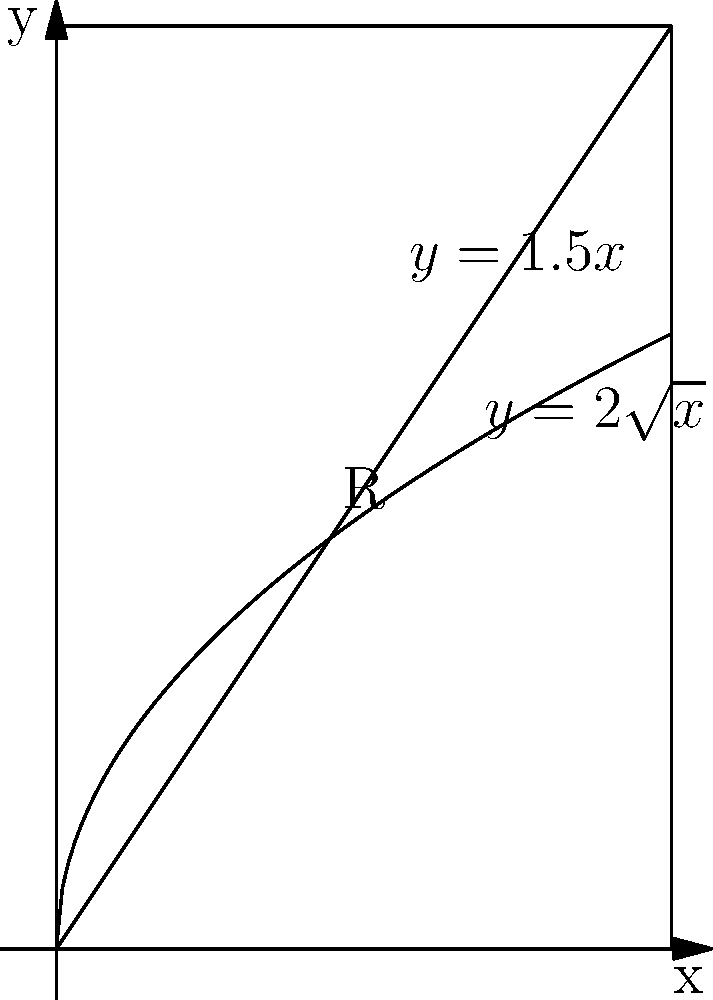As a concert promoter organizing a Queen tribute show, you're designing a cylindrical speaker stack. The cross-section of the stack is represented by the region R bounded by the curves $y=2\sqrt{x}$, $y=1.5x$, and the y-axis. If the stack is 10 feet tall, what is its volume in cubic feet? Round your answer to the nearest whole number. To find the volume of the cylindrical speaker stack, we need to follow these steps:

1) First, we need to find the area of the cross-section (region R) using the washer method.

2) The area A is given by the integral:

   $$A = \int_0^a (2\sqrt{x} - 1.5x) dx$$

   where $a$ is the x-coordinate of the intersection point of the two curves.

3) To find $a$, we solve the equation:
   
   $$2\sqrt{x} = 1.5x$$
   $$4x = 2.25x^2$$
   $$0 = 2.25x^2 - 4x = 0.25x(9x - 16)$$
   $$x = 0 \text{ or } x = \frac{16}{9}$$

   The non-zero solution is $a = \frac{16}{9}$.

4) Now we can evaluate the integral:

   $$A = \int_0^{16/9} (2\sqrt{x} - 1.5x) dx$$
   $$= [2\frac{2}{3}x^{3/2} - \frac{3}{4}x^2]_0^{16/9}$$
   $$= (2\frac{2}{3}(\frac{16}{9})^{3/2} - \frac{3}{4}(\frac{16}{9})^2) - 0$$
   $$= \frac{32}{27}\sqrt{\frac{16}{9}} - \frac{192}{81}$$
   $$= \frac{128}{81} - \frac{192}{81} = -\frac{64}{81}$$
   $$= \frac{64}{81} \text{ sq ft} \text{ (we take the absolute value) }$$

5) The volume V of the cylindrical stack is the area of the cross-section multiplied by the height:

   $$V = A \cdot h = \frac{64}{81} \cdot 10 = \frac{640}{81} \approx 7.90 \text{ cubic feet}$$

6) Rounding to the nearest whole number, we get 8 cubic feet.
Answer: 8 cubic feet 